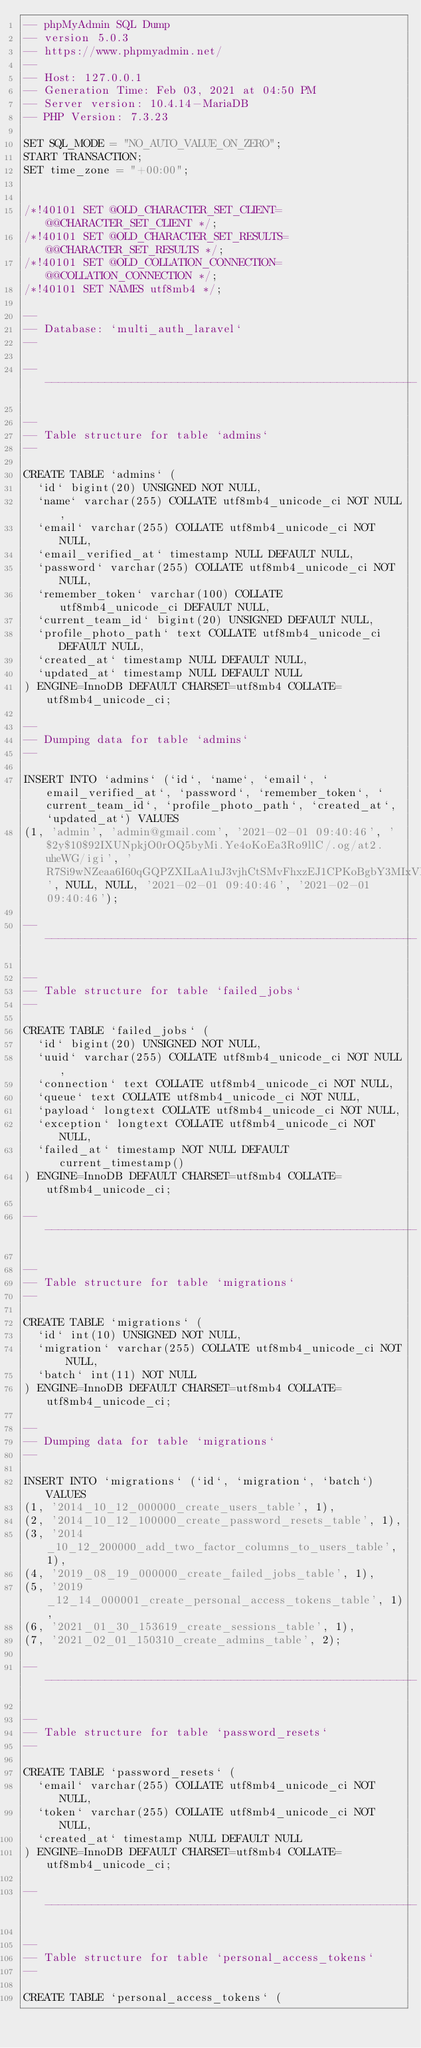Convert code to text. <code><loc_0><loc_0><loc_500><loc_500><_SQL_>-- phpMyAdmin SQL Dump
-- version 5.0.3
-- https://www.phpmyadmin.net/
--
-- Host: 127.0.0.1
-- Generation Time: Feb 03, 2021 at 04:50 PM
-- Server version: 10.4.14-MariaDB
-- PHP Version: 7.3.23

SET SQL_MODE = "NO_AUTO_VALUE_ON_ZERO";
START TRANSACTION;
SET time_zone = "+00:00";


/*!40101 SET @OLD_CHARACTER_SET_CLIENT=@@CHARACTER_SET_CLIENT */;
/*!40101 SET @OLD_CHARACTER_SET_RESULTS=@@CHARACTER_SET_RESULTS */;
/*!40101 SET @OLD_COLLATION_CONNECTION=@@COLLATION_CONNECTION */;
/*!40101 SET NAMES utf8mb4 */;

--
-- Database: `multi_auth_laravel`
--

-- --------------------------------------------------------

--
-- Table structure for table `admins`
--

CREATE TABLE `admins` (
  `id` bigint(20) UNSIGNED NOT NULL,
  `name` varchar(255) COLLATE utf8mb4_unicode_ci NOT NULL,
  `email` varchar(255) COLLATE utf8mb4_unicode_ci NOT NULL,
  `email_verified_at` timestamp NULL DEFAULT NULL,
  `password` varchar(255) COLLATE utf8mb4_unicode_ci NOT NULL,
  `remember_token` varchar(100) COLLATE utf8mb4_unicode_ci DEFAULT NULL,
  `current_team_id` bigint(20) UNSIGNED DEFAULT NULL,
  `profile_photo_path` text COLLATE utf8mb4_unicode_ci DEFAULT NULL,
  `created_at` timestamp NULL DEFAULT NULL,
  `updated_at` timestamp NULL DEFAULT NULL
) ENGINE=InnoDB DEFAULT CHARSET=utf8mb4 COLLATE=utf8mb4_unicode_ci;

--
-- Dumping data for table `admins`
--

INSERT INTO `admins` (`id`, `name`, `email`, `email_verified_at`, `password`, `remember_token`, `current_team_id`, `profile_photo_path`, `created_at`, `updated_at`) VALUES
(1, 'admin', 'admin@gmail.com', '2021-02-01 09:40:46', '$2y$10$92IXUNpkjO0rOQ5byMi.Ye4oKoEa3Ro9llC/.og/at2.uheWG/igi', 'R7Si9wNZeaa6I60qGQPZXILaA1uJ3vjhCtSMvFhxzEJ1CPKoBgbY3MIxVHYp', NULL, NULL, '2021-02-01 09:40:46', '2021-02-01 09:40:46');

-- --------------------------------------------------------

--
-- Table structure for table `failed_jobs`
--

CREATE TABLE `failed_jobs` (
  `id` bigint(20) UNSIGNED NOT NULL,
  `uuid` varchar(255) COLLATE utf8mb4_unicode_ci NOT NULL,
  `connection` text COLLATE utf8mb4_unicode_ci NOT NULL,
  `queue` text COLLATE utf8mb4_unicode_ci NOT NULL,
  `payload` longtext COLLATE utf8mb4_unicode_ci NOT NULL,
  `exception` longtext COLLATE utf8mb4_unicode_ci NOT NULL,
  `failed_at` timestamp NOT NULL DEFAULT current_timestamp()
) ENGINE=InnoDB DEFAULT CHARSET=utf8mb4 COLLATE=utf8mb4_unicode_ci;

-- --------------------------------------------------------

--
-- Table structure for table `migrations`
--

CREATE TABLE `migrations` (
  `id` int(10) UNSIGNED NOT NULL,
  `migration` varchar(255) COLLATE utf8mb4_unicode_ci NOT NULL,
  `batch` int(11) NOT NULL
) ENGINE=InnoDB DEFAULT CHARSET=utf8mb4 COLLATE=utf8mb4_unicode_ci;

--
-- Dumping data for table `migrations`
--

INSERT INTO `migrations` (`id`, `migration`, `batch`) VALUES
(1, '2014_10_12_000000_create_users_table', 1),
(2, '2014_10_12_100000_create_password_resets_table', 1),
(3, '2014_10_12_200000_add_two_factor_columns_to_users_table', 1),
(4, '2019_08_19_000000_create_failed_jobs_table', 1),
(5, '2019_12_14_000001_create_personal_access_tokens_table', 1),
(6, '2021_01_30_153619_create_sessions_table', 1),
(7, '2021_02_01_150310_create_admins_table', 2);

-- --------------------------------------------------------

--
-- Table structure for table `password_resets`
--

CREATE TABLE `password_resets` (
  `email` varchar(255) COLLATE utf8mb4_unicode_ci NOT NULL,
  `token` varchar(255) COLLATE utf8mb4_unicode_ci NOT NULL,
  `created_at` timestamp NULL DEFAULT NULL
) ENGINE=InnoDB DEFAULT CHARSET=utf8mb4 COLLATE=utf8mb4_unicode_ci;

-- --------------------------------------------------------

--
-- Table structure for table `personal_access_tokens`
--

CREATE TABLE `personal_access_tokens` (</code> 